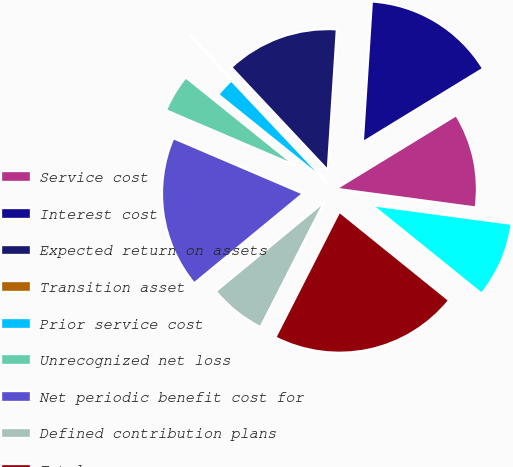Convert chart to OTSL. <chart><loc_0><loc_0><loc_500><loc_500><pie_chart><fcel>Service cost<fcel>Interest cost<fcel>Expected return on assets<fcel>Transition asset<fcel>Prior service cost<fcel>Unrecognized net loss<fcel>Net periodic benefit cost for<fcel>Defined contribution plans<fcel>Total<fcel>Net periodic benefit cost<nl><fcel>10.86%<fcel>15.24%<fcel>13.02%<fcel>0.03%<fcel>2.19%<fcel>4.36%<fcel>17.4%<fcel>6.53%<fcel>21.69%<fcel>8.69%<nl></chart> 